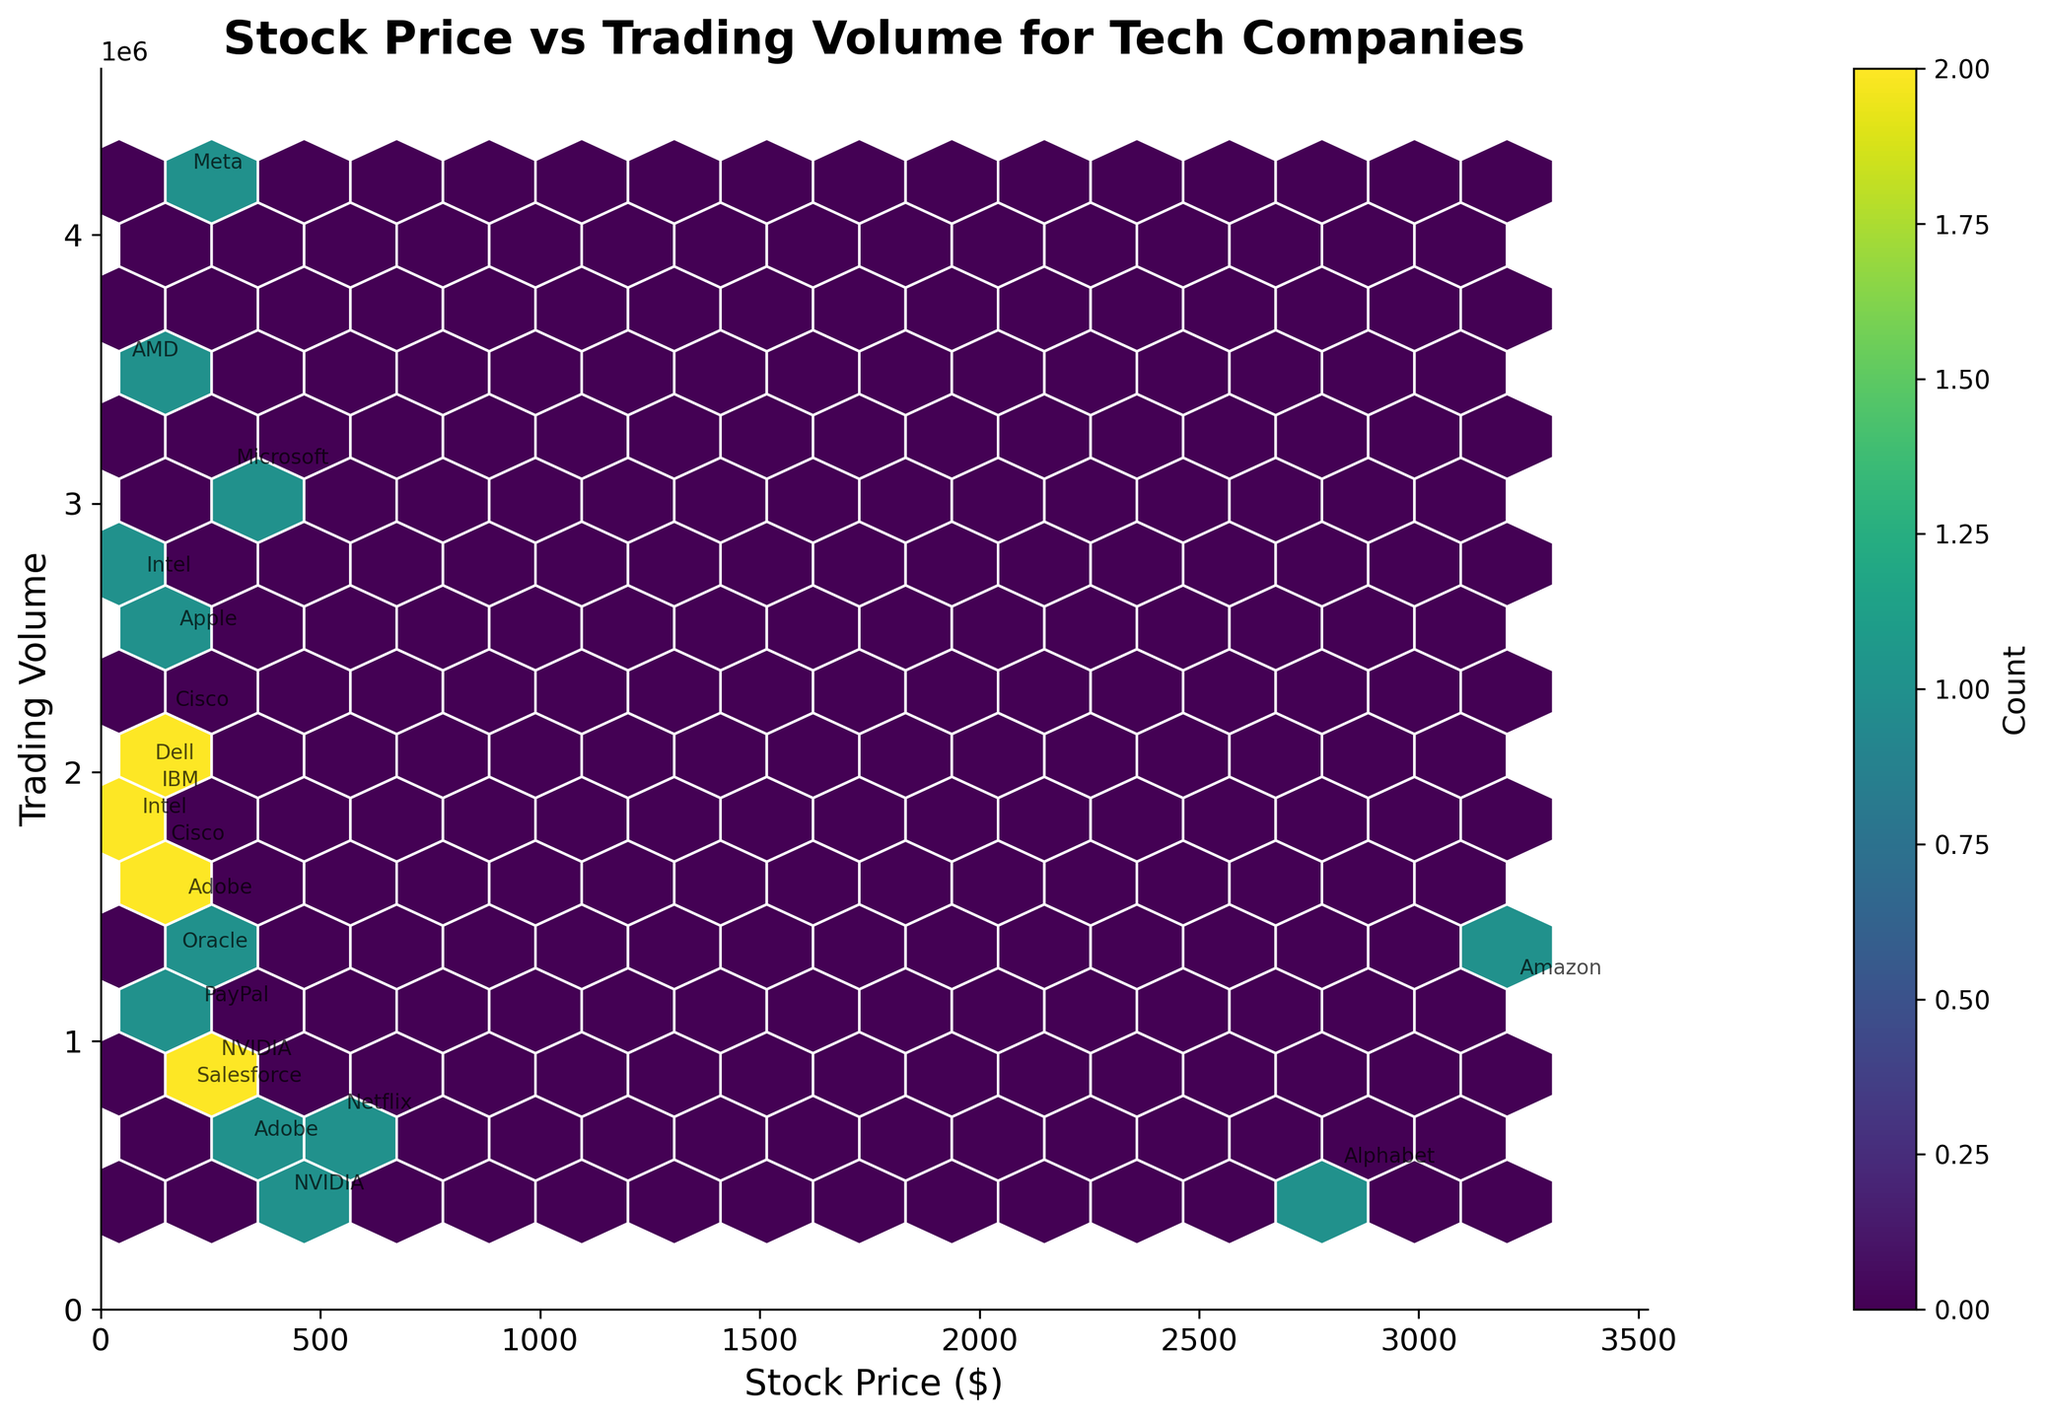What's the title of the figure? The title is usually displayed at the top of the figure, summarizing what the figure is about. In this case, the title provided in the code is "Stock Price vs Trading Volume for Tech Companies".
Answer: Stock Price vs Trading Volume for Tech Companies What does the color intensity represent in the figure? The color intensity in a hexbin plot represents the count of data points within each hexagon. Darker areas indicate higher counts. This is usually explained by the color bar labeled "Count".
Answer: Count of data points Which companies have stock prices above $1000 and what are their trading volumes? By focusing on the annotations, we identify companies with stock prices above $1000, then check their corresponding trading volumes. In this case, Apple, Amazon, and Alphabet meet this criterion. Their trading volumes are 2,500,000 (Apple), 1,200,000 (Amazon), and 500,000 (Alphabet).
Answer: Apple, Amazon, Alphabet: 2,500,000, 1,200,000, 500,000 What is the trading volume for the company with the highest stock price? Look for the company with the highest stock price by comparing the annotations and then refer to its trading volume. Amazon has the highest stock price of $3200.75 and a trading volume of 1,200,000.
Answer: 1,200,000 Which companies have the highest concentration of data points in their price and volume range? Identify the areas with the most intense color in the hexbin plot and look at the annotations. This indicates high data concentration. The mid-range stock price (around $100-$300) and trading volumes (around 1,000,000-3,000,000) show companies like Microsoft, Intel, Adobe, and Cisco.
Answer: Microsoft, Intel, Adobe, Cisco How many companies have a stock price below $100? By visually inspecting the hexbin plot and checking the annotations, we count the companies with stock prices below $100. AMD, Cisco, and Dell fall into this category.
Answer: 3 Which company is associated with a trading volume of about 2,200,000 units? Check the trading volume annotations close to 2,200,000 and identify the company. Cisco has a trading volume of 2,200,000 units.
Answer: Cisco What is the average trading volume of companies with stock prices below $200? Identify companies with stock prices below $200: Meta (4,200,000), Intel (1,800,000 and 2,700,000), Adobe (1,500,000 and 600,000), Cisco (2,200,000 and 1,700,000), AMD (3,500,000), IBM (1,900,000), Oracle (1,300,000), Salesforce (800,000), PayPal (1,100,000), Dell (2,000,000). Sum the trading volumes: \(4,200,000 + 1,800,000 + 2,700,000 + 1,500,000 + 600,000 + 2,200,000 + 1,700,000 + 3,500,000 + 1,900,000 + 1,300,000 + 800,000 + 1,100,000 + 2,000,000 = 28,300,000\). Divide by the number of companies \(13\): 
\(\frac{28,300,000}{13} \approx 2,176,923\).
Answer: 2,176,923 Which company has the lowest trading volume and what is its stock price? Look for the annotation with the lowest trading volume and identify the company and its stock price. Alphabet has the lowest trading volume of 500,000, with a stock price of 2800.00.
Answer: Alphabet, 2800.00 